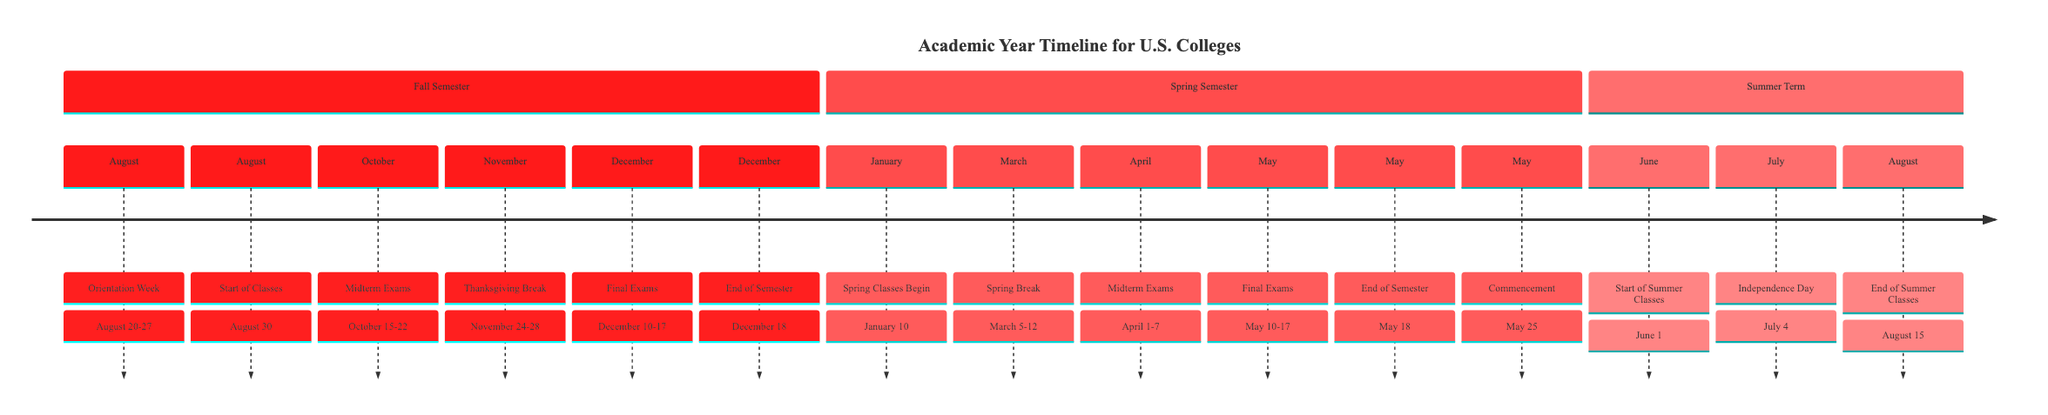What month does the Fall Semester start? The diagram indicates that the Fall Semester starts with Orientation Week, which begins in August.
Answer: August How many key events are listed for the Spring Semester? By examining the timeline, the Spring Semester has six key events detailed from January to May.
Answer: 6 What is the last event of the Fall Semester? According to the timeline, the last event of the Fall Semester is the End of Semester, which occurs on December 18.
Answer: End of Semester What is the date range for Midterm Exams in the Spring Semester? The timeline specifies that Midterm Exams are held from April 1 to April 7 during the Spring Semester.
Answer: April 1-7 Which holiday falls in July during the Summer Term? The timeline shows that Independence Day is the holiday on July 4, during the Summer Term.
Answer: Independence Day When do Spring Classes begin? The timeline clearly indicates that Spring Classes Begin on January 10.
Answer: January 10 How long is the Thanksgiving Break? The diagram informs us that Thanksgiving Break lasts from November 24 to November 28, which is a five-day break.
Answer: November 24-28 What is the final event listed in the timeline? Reviewing the entire timeline, the final event is Commencement on May 25.
Answer: Commencement Which semester has a break in March? The Spring Semester features Spring Break, which occurs from March 5 to March 12, indicating that this is the semester with a break in March.
Answer: Spring Semester 